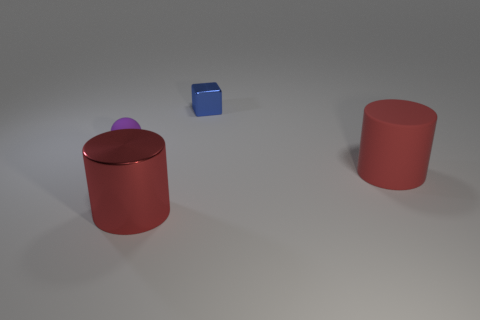Add 3 big red rubber cylinders. How many objects exist? 7 Subtract all cubes. How many objects are left? 3 Subtract 1 red cylinders. How many objects are left? 3 Subtract all red metal objects. Subtract all cubes. How many objects are left? 2 Add 3 small blue objects. How many small blue objects are left? 4 Add 1 small balls. How many small balls exist? 2 